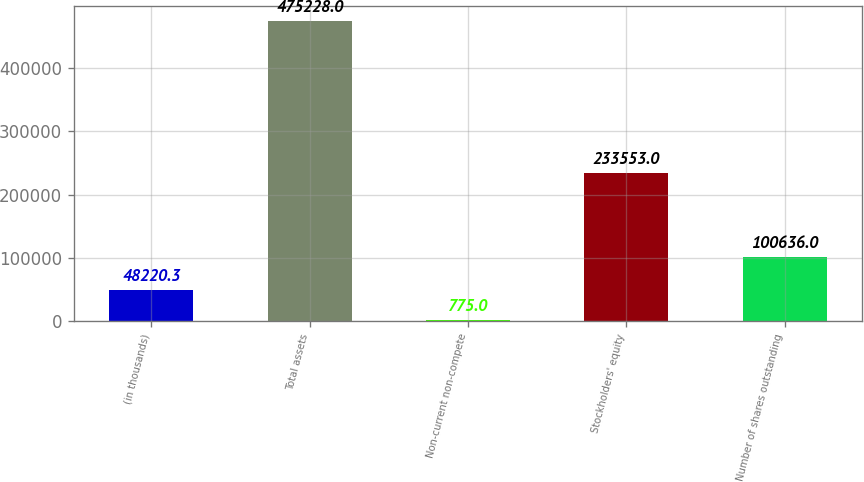<chart> <loc_0><loc_0><loc_500><loc_500><bar_chart><fcel>(in thousands)<fcel>Total assets<fcel>Non-current non-compete<fcel>Stockholders' equity<fcel>Number of shares outstanding<nl><fcel>48220.3<fcel>475228<fcel>775<fcel>233553<fcel>100636<nl></chart> 